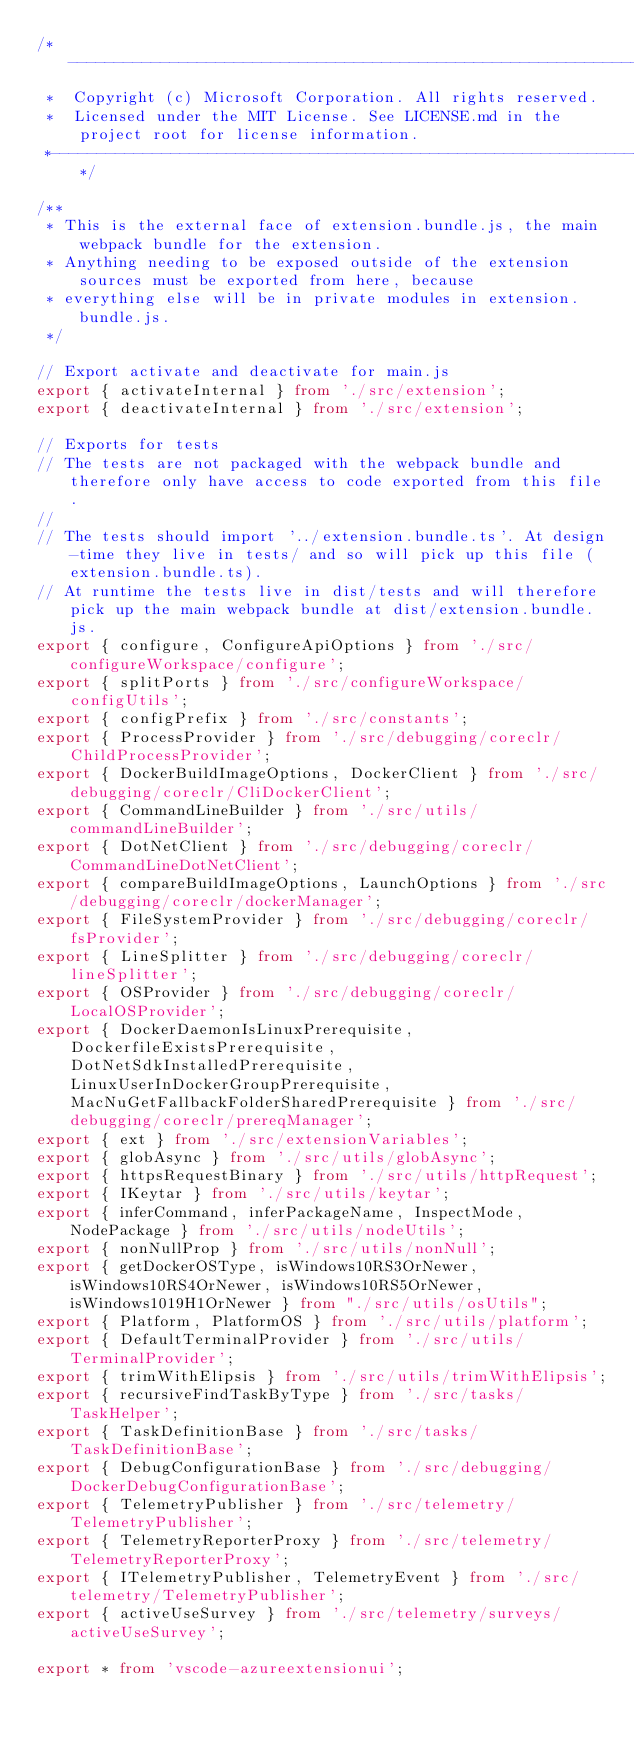Convert code to text. <code><loc_0><loc_0><loc_500><loc_500><_TypeScript_>/*---------------------------------------------------------------------------------------------
 *  Copyright (c) Microsoft Corporation. All rights reserved.
 *  Licensed under the MIT License. See LICENSE.md in the project root for license information.
 *--------------------------------------------------------------------------------------------*/

/**
 * This is the external face of extension.bundle.js, the main webpack bundle for the extension.
 * Anything needing to be exposed outside of the extension sources must be exported from here, because
 * everything else will be in private modules in extension.bundle.js.
 */

// Export activate and deactivate for main.js
export { activateInternal } from './src/extension';
export { deactivateInternal } from './src/extension';

// Exports for tests
// The tests are not packaged with the webpack bundle and therefore only have access to code exported from this file.
//
// The tests should import '../extension.bundle.ts'. At design-time they live in tests/ and so will pick up this file (extension.bundle.ts).
// At runtime the tests live in dist/tests and will therefore pick up the main webpack bundle at dist/extension.bundle.js.
export { configure, ConfigureApiOptions } from './src/configureWorkspace/configure';
export { splitPorts } from './src/configureWorkspace/configUtils';
export { configPrefix } from './src/constants';
export { ProcessProvider } from './src/debugging/coreclr/ChildProcessProvider';
export { DockerBuildImageOptions, DockerClient } from './src/debugging/coreclr/CliDockerClient';
export { CommandLineBuilder } from './src/utils/commandLineBuilder';
export { DotNetClient } from './src/debugging/coreclr/CommandLineDotNetClient';
export { compareBuildImageOptions, LaunchOptions } from './src/debugging/coreclr/dockerManager';
export { FileSystemProvider } from './src/debugging/coreclr/fsProvider';
export { LineSplitter } from './src/debugging/coreclr/lineSplitter';
export { OSProvider } from './src/debugging/coreclr/LocalOSProvider';
export { DockerDaemonIsLinuxPrerequisite, DockerfileExistsPrerequisite, DotNetSdkInstalledPrerequisite, LinuxUserInDockerGroupPrerequisite, MacNuGetFallbackFolderSharedPrerequisite } from './src/debugging/coreclr/prereqManager';
export { ext } from './src/extensionVariables';
export { globAsync } from './src/utils/globAsync';
export { httpsRequestBinary } from './src/utils/httpRequest';
export { IKeytar } from './src/utils/keytar';
export { inferCommand, inferPackageName, InspectMode, NodePackage } from './src/utils/nodeUtils';
export { nonNullProp } from './src/utils/nonNull';
export { getDockerOSType, isWindows10RS3OrNewer, isWindows10RS4OrNewer, isWindows10RS5OrNewer, isWindows1019H1OrNewer } from "./src/utils/osUtils";
export { Platform, PlatformOS } from './src/utils/platform';
export { DefaultTerminalProvider } from './src/utils/TerminalProvider';
export { trimWithElipsis } from './src/utils/trimWithElipsis';
export { recursiveFindTaskByType } from './src/tasks/TaskHelper';
export { TaskDefinitionBase } from './src/tasks/TaskDefinitionBase';
export { DebugConfigurationBase } from './src/debugging/DockerDebugConfigurationBase';
export { TelemetryPublisher } from './src/telemetry/TelemetryPublisher';
export { TelemetryReporterProxy } from './src/telemetry/TelemetryReporterProxy';
export { ITelemetryPublisher, TelemetryEvent } from './src/telemetry/TelemetryPublisher';
export { activeUseSurvey } from './src/telemetry/surveys/activeUseSurvey';

export * from 'vscode-azureextensionui';
</code> 